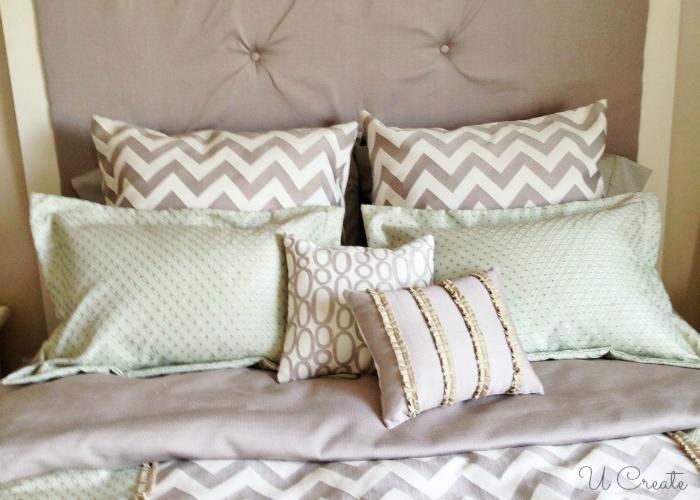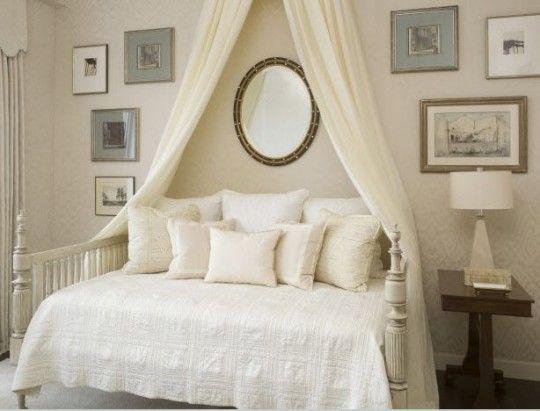The first image is the image on the left, the second image is the image on the right. Analyze the images presented: Is the assertion "Rumpled sheets and pillows of an unmade bed are shown in one image." valid? Answer yes or no. No. 